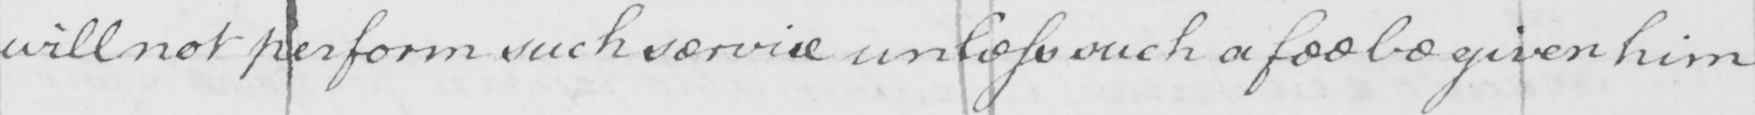Please provide the text content of this handwritten line. will not perform such service unless such a fee be given him 